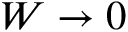<formula> <loc_0><loc_0><loc_500><loc_500>W \rightarrow 0</formula> 